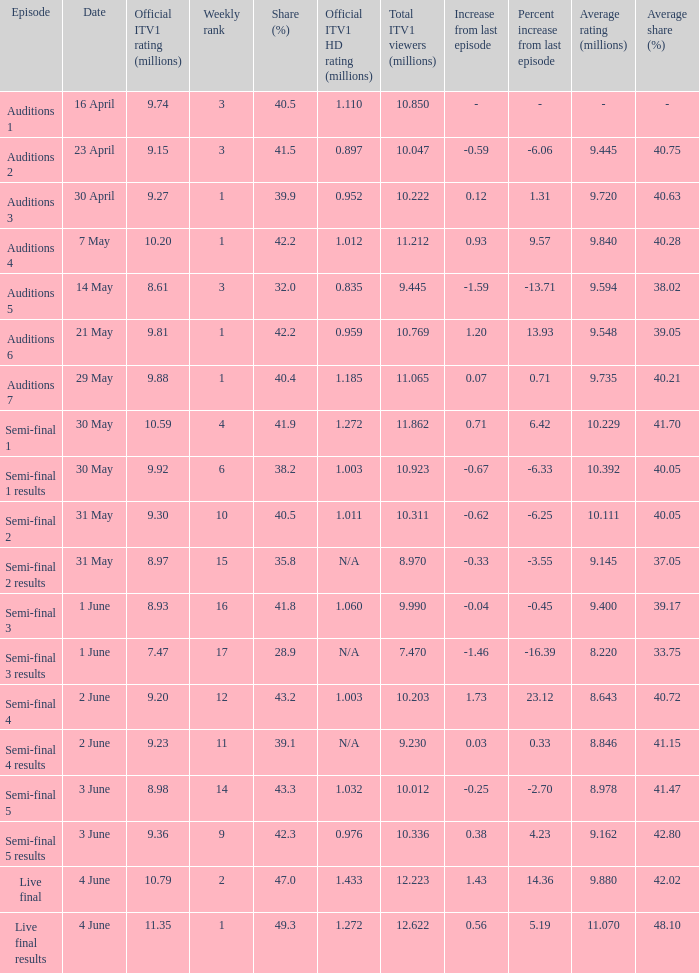What was the official ITV1 HD rating in millions for the episode that had an official ITV1 rating of 8.98 million? 1.032. 